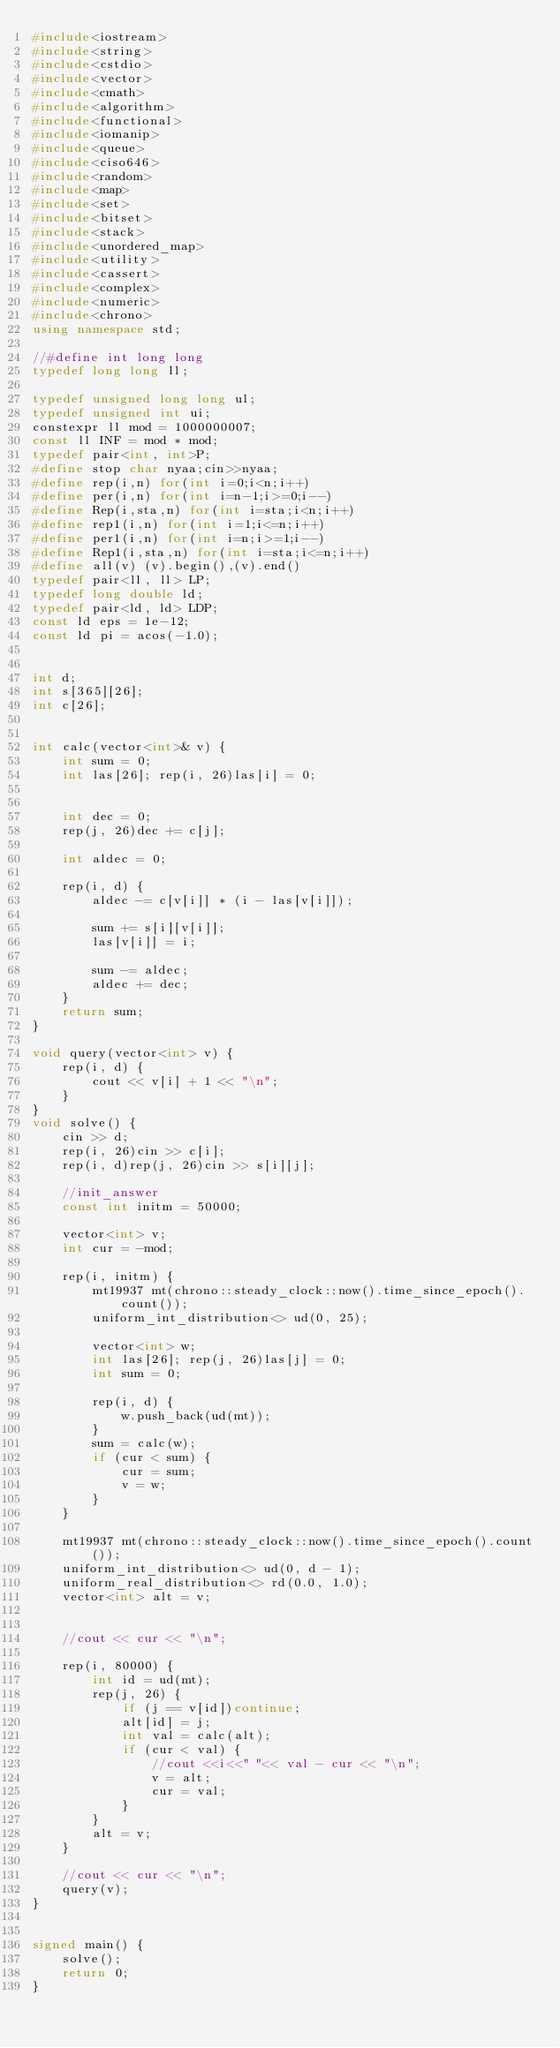<code> <loc_0><loc_0><loc_500><loc_500><_C++_>#include<iostream>
#include<string>
#include<cstdio>
#include<vector>
#include<cmath>
#include<algorithm>
#include<functional>
#include<iomanip>
#include<queue>
#include<ciso646>
#include<random>
#include<map>
#include<set>
#include<bitset>
#include<stack>
#include<unordered_map>
#include<utility>
#include<cassert>
#include<complex>
#include<numeric>
#include<chrono>
using namespace std;

//#define int long long
typedef long long ll;

typedef unsigned long long ul;
typedef unsigned int ui;
constexpr ll mod = 1000000007;
const ll INF = mod * mod;
typedef pair<int, int>P;
#define stop char nyaa;cin>>nyaa;
#define rep(i,n) for(int i=0;i<n;i++)
#define per(i,n) for(int i=n-1;i>=0;i--)
#define Rep(i,sta,n) for(int i=sta;i<n;i++)
#define rep1(i,n) for(int i=1;i<=n;i++)
#define per1(i,n) for(int i=n;i>=1;i--)
#define Rep1(i,sta,n) for(int i=sta;i<=n;i++)
#define all(v) (v).begin(),(v).end()
typedef pair<ll, ll> LP;
typedef long double ld;
typedef pair<ld, ld> LDP;
const ld eps = 1e-12;
const ld pi = acos(-1.0);


int d;
int s[365][26];
int c[26];


int calc(vector<int>& v) {
	int sum = 0;
	int las[26]; rep(i, 26)las[i] = 0;


	int dec = 0;
	rep(j, 26)dec += c[j];

	int aldec = 0;

	rep(i, d) {
		aldec -= c[v[i]] * (i - las[v[i]]);

		sum += s[i][v[i]];
		las[v[i]] = i;

		sum -= aldec;
		aldec += dec;
	}
	return sum;
}

void query(vector<int> v) {
	rep(i, d) {
		cout << v[i] + 1 << "\n";
	}
}
void solve() {
	cin >> d;
	rep(i, 26)cin >> c[i];
	rep(i, d)rep(j, 26)cin >> s[i][j];

	//init_answer
	const int initm = 50000;

	vector<int> v;
	int cur = -mod;

	rep(i, initm) {
		mt19937 mt(chrono::steady_clock::now().time_since_epoch().count());
		uniform_int_distribution<> ud(0, 25);

		vector<int> w;
		int las[26]; rep(j, 26)las[j] = 0;
		int sum = 0;

		rep(i, d) {
			w.push_back(ud(mt));
		}
		sum = calc(w);
		if (cur < sum) {
			cur = sum;
			v = w;
		}
	}

	mt19937 mt(chrono::steady_clock::now().time_since_epoch().count());
	uniform_int_distribution<> ud(0, d - 1);
	uniform_real_distribution<> rd(0.0, 1.0);
	vector<int> alt = v;


	//cout << cur << "\n";

	rep(i, 80000) {
		int id = ud(mt);
		rep(j, 26) {
			if (j == v[id])continue;
			alt[id] = j;
			int val = calc(alt);
			if (cur < val) {
				//cout <<i<<" "<< val - cur << "\n";
				v = alt;
				cur = val;
			}
		}
		alt = v;
	}

	//cout << cur << "\n";
	query(v);
}


signed main() {
	solve();
	return 0;
}
</code> 